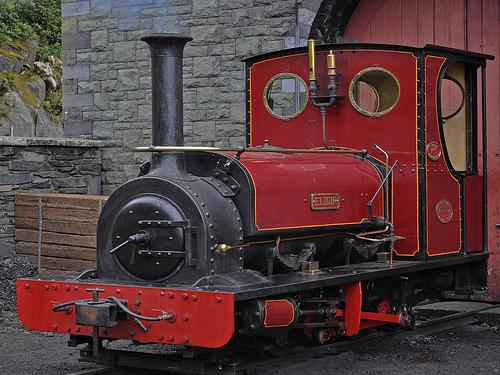Question: what is the focus?
Choices:
A. Locomotive train.
B. The child.
C. The fruit bowl.
D. The architecture.
Answer with the letter. Answer: A Question: what is the train station made of?
Choices:
A. Brick.
B. Stone.
C. Wood.
D. Steel.
Answer with the letter. Answer: B 